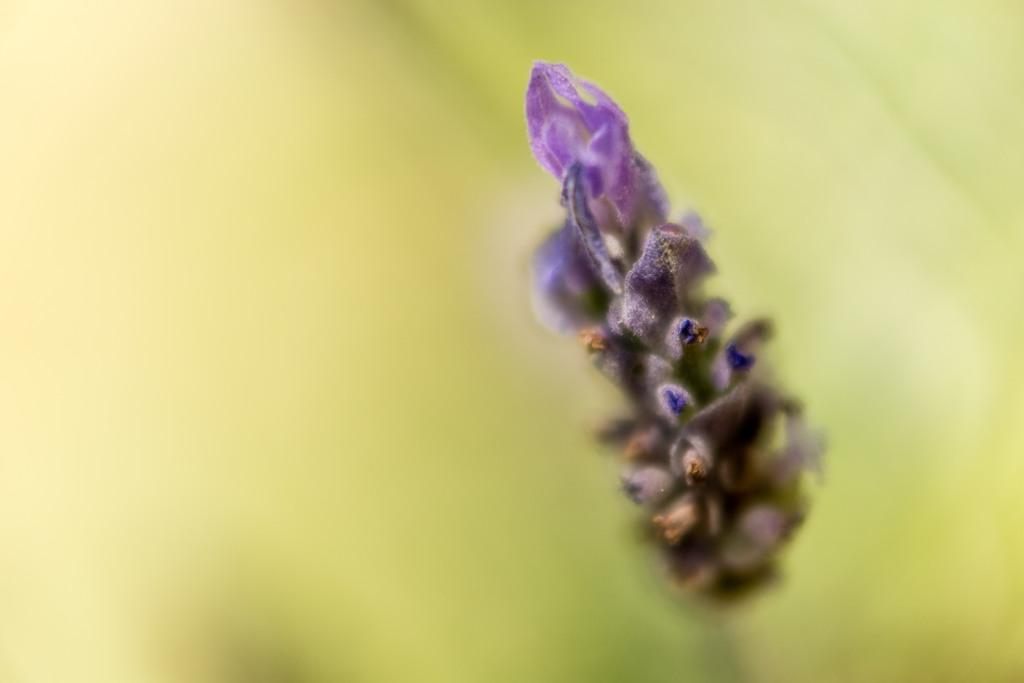What color is the flower in the image? The flower is purple. How many divisions are present in the flower in the image? There is no information about divisions in the flower in the image, as only its color is mentioned. 